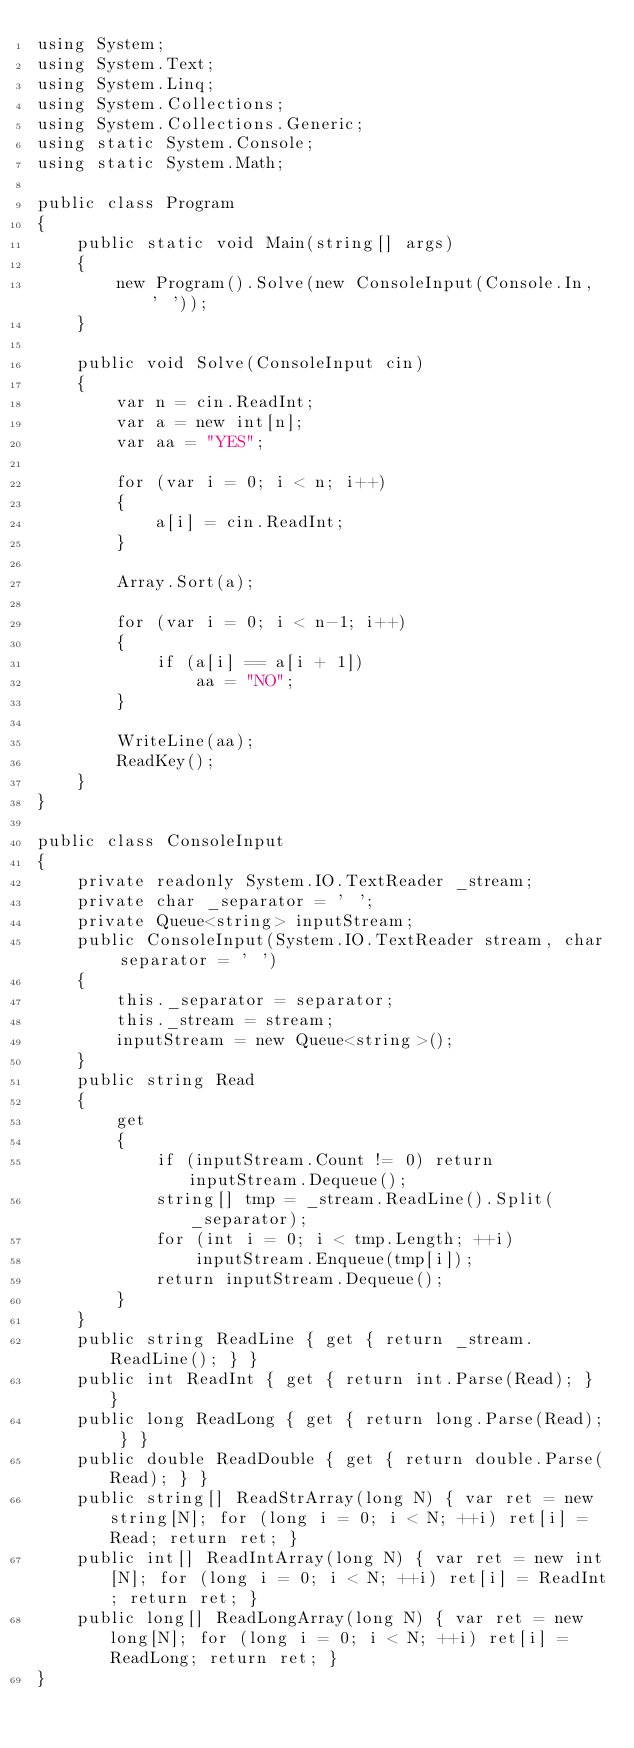Convert code to text. <code><loc_0><loc_0><loc_500><loc_500><_C#_>using System;
using System.Text;
using System.Linq;
using System.Collections;
using System.Collections.Generic;
using static System.Console;
using static System.Math;

public class Program
{
    public static void Main(string[] args)
    {
        new Program().Solve(new ConsoleInput(Console.In, ' '));
    }

    public void Solve(ConsoleInput cin)
    {
        var n = cin.ReadInt;
        var a = new int[n];
        var aa = "YES";

        for (var i = 0; i < n; i++)
        {
            a[i] = cin.ReadInt;
        }

        Array.Sort(a);

        for (var i = 0; i < n-1; i++)
        {
            if (a[i] == a[i + 1])
                aa = "NO";
        }

        WriteLine(aa);
        ReadKey();
    }
}

public class ConsoleInput
{
    private readonly System.IO.TextReader _stream;
    private char _separator = ' ';
    private Queue<string> inputStream;
    public ConsoleInput(System.IO.TextReader stream, char separator = ' ')
    {
        this._separator = separator;
        this._stream = stream;
        inputStream = new Queue<string>();
    }
    public string Read
    {
        get
        {
            if (inputStream.Count != 0) return inputStream.Dequeue();
            string[] tmp = _stream.ReadLine().Split(_separator);
            for (int i = 0; i < tmp.Length; ++i)
                inputStream.Enqueue(tmp[i]);
            return inputStream.Dequeue();
        }
    }
    public string ReadLine { get { return _stream.ReadLine(); } }
    public int ReadInt { get { return int.Parse(Read); } }
    public long ReadLong { get { return long.Parse(Read); } }
    public double ReadDouble { get { return double.Parse(Read); } }
    public string[] ReadStrArray(long N) { var ret = new string[N]; for (long i = 0; i < N; ++i) ret[i] = Read; return ret; }
    public int[] ReadIntArray(long N) { var ret = new int[N]; for (long i = 0; i < N; ++i) ret[i] = ReadInt; return ret; }
    public long[] ReadLongArray(long N) { var ret = new long[N]; for (long i = 0; i < N; ++i) ret[i] = ReadLong; return ret; }
}
</code> 